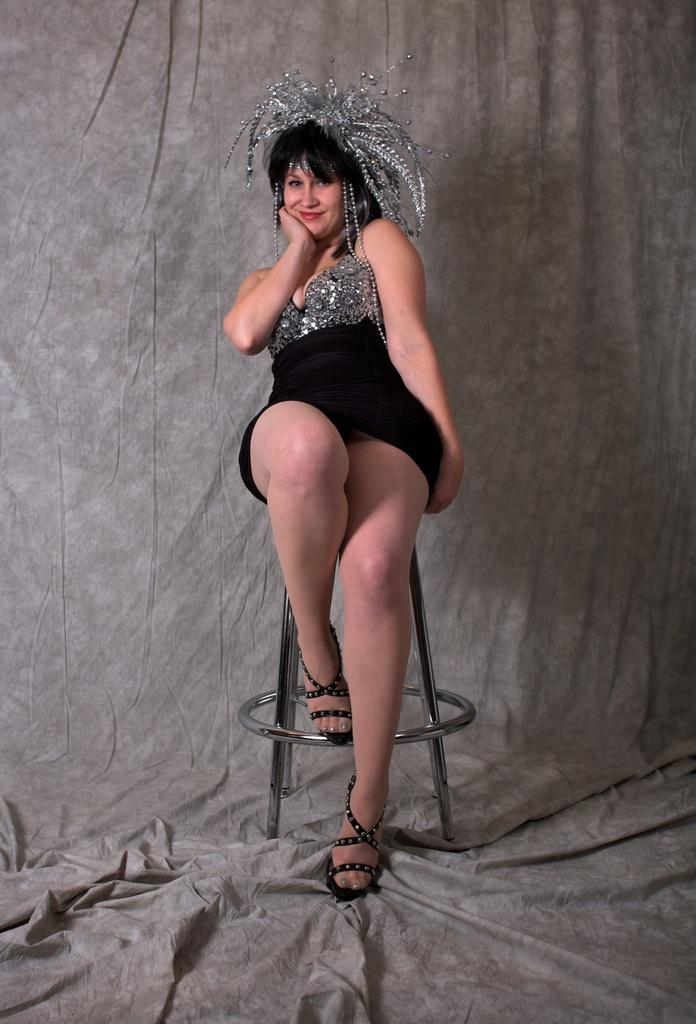Who is the main subject in the image? There is a woman in the image. What is the woman wearing? The woman is wearing a black dress. What accessory is the woman wearing on her head? The woman has a crown on her head. What is the woman doing in the image? The woman is sitting on a chair, smiling, and giving a pose for the picture. What can be seen in the background of the image? There is a curtain visible in the background. What type of pipe is the woman smoking in the image? There is no pipe present in the image; the woman is wearing a crown and sitting on a chair. 